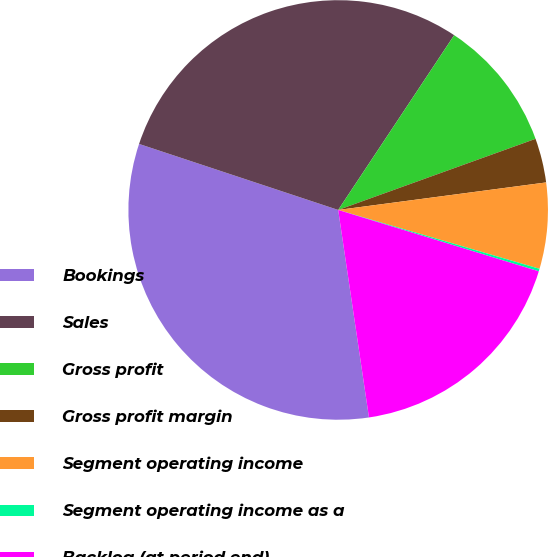Convert chart to OTSL. <chart><loc_0><loc_0><loc_500><loc_500><pie_chart><fcel>Bookings<fcel>Sales<fcel>Gross profit<fcel>Gross profit margin<fcel>Segment operating income<fcel>Segment operating income as a<fcel>Backlog (at period end)<nl><fcel>32.44%<fcel>29.23%<fcel>10.17%<fcel>3.41%<fcel>6.62%<fcel>0.2%<fcel>17.93%<nl></chart> 